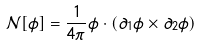<formula> <loc_0><loc_0><loc_500><loc_500>\mathcal { N } [ \phi ] = \frac { 1 } { 4 \pi } \phi \cdot ( \partial _ { 1 } \phi \times \partial _ { 2 } \phi )</formula> 